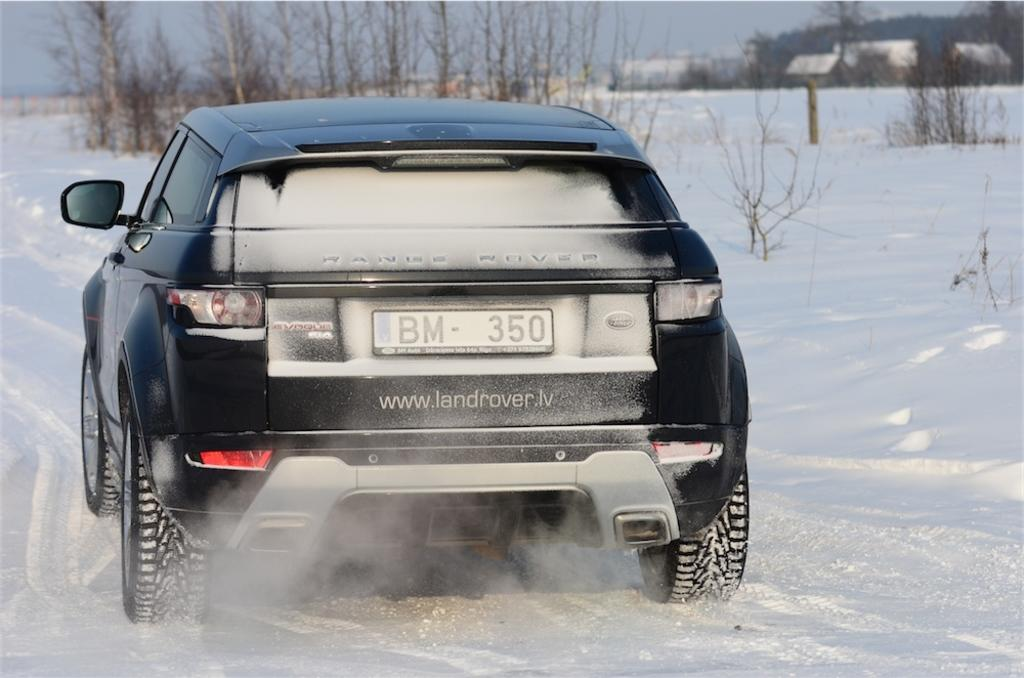<image>
Summarize the visual content of the image. a black land rover plows through the snow with www.landrover.lv written on the back 